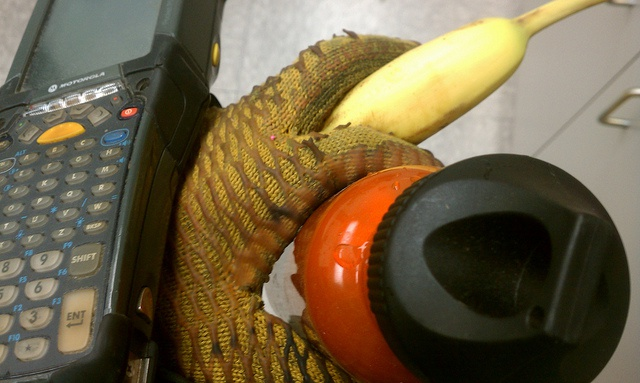Describe the objects in this image and their specific colors. I can see bottle in darkgray, black, red, maroon, and gray tones and banana in darkgray, khaki, tan, and lightyellow tones in this image. 